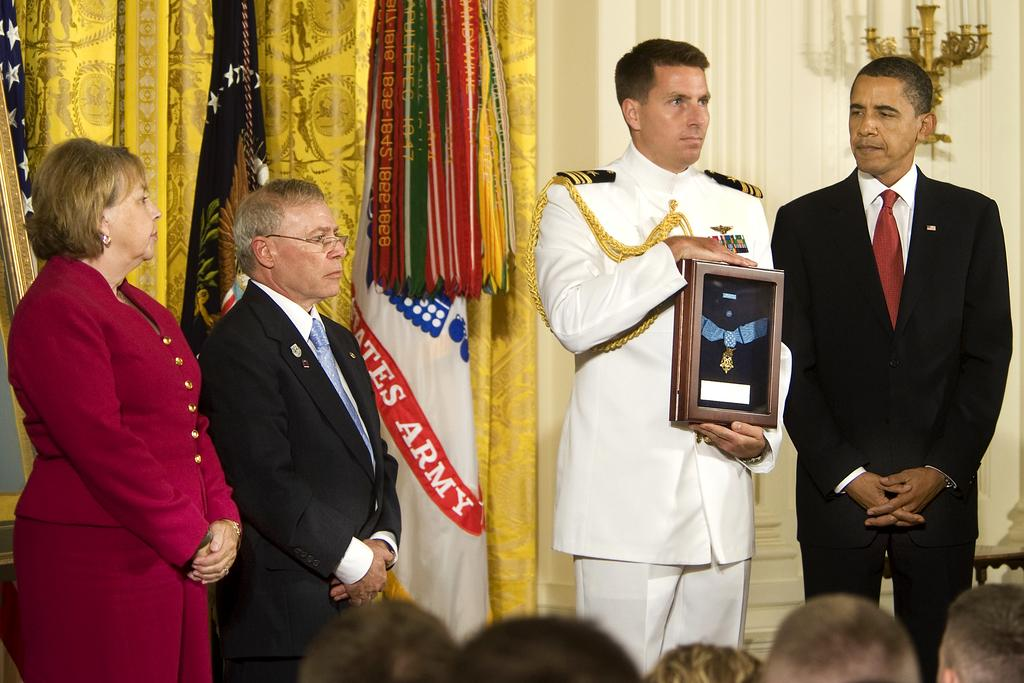Provide a one-sentence caption for the provided image. a man in the army accepting a medal from the president. 